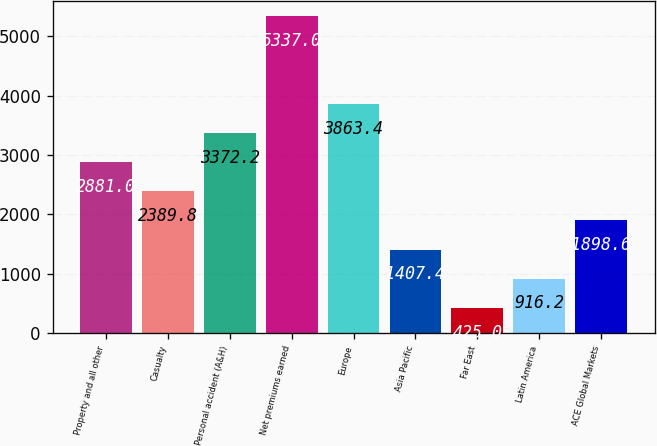<chart> <loc_0><loc_0><loc_500><loc_500><bar_chart><fcel>Property and all other<fcel>Casualty<fcel>Personal accident (A&H)<fcel>Net premiums earned<fcel>Europe<fcel>Asia Pacific<fcel>Far East<fcel>Latin America<fcel>ACE Global Markets<nl><fcel>2881<fcel>2389.8<fcel>3372.2<fcel>5337<fcel>3863.4<fcel>1407.4<fcel>425<fcel>916.2<fcel>1898.6<nl></chart> 